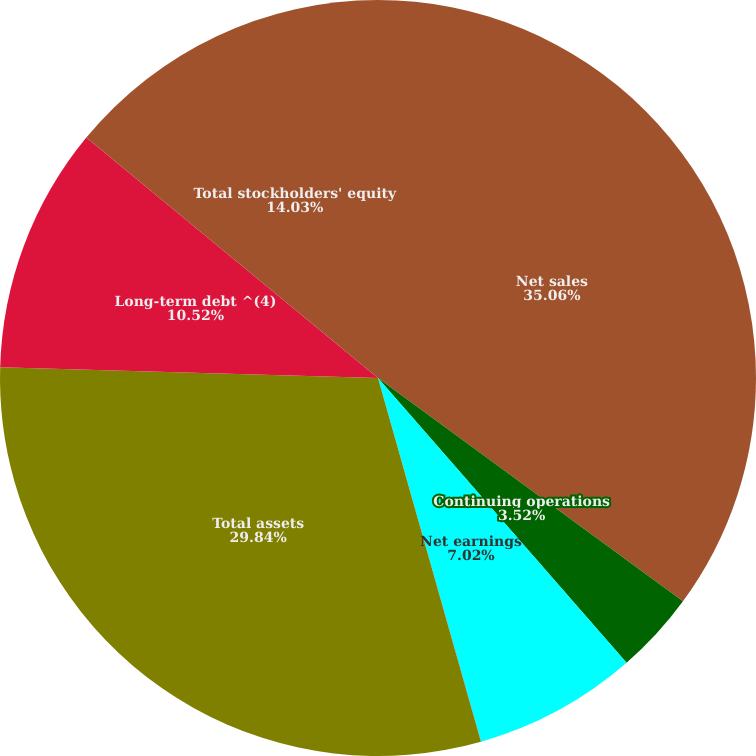Convert chart. <chart><loc_0><loc_0><loc_500><loc_500><pie_chart><fcel>Net sales<fcel>Continuing operations<fcel>Net earnings<fcel>Cash dividends per common<fcel>Total assets<fcel>Long-term debt ^(4)<fcel>Total stockholders' equity<nl><fcel>35.06%<fcel>3.52%<fcel>7.02%<fcel>0.01%<fcel>29.84%<fcel>10.52%<fcel>14.03%<nl></chart> 